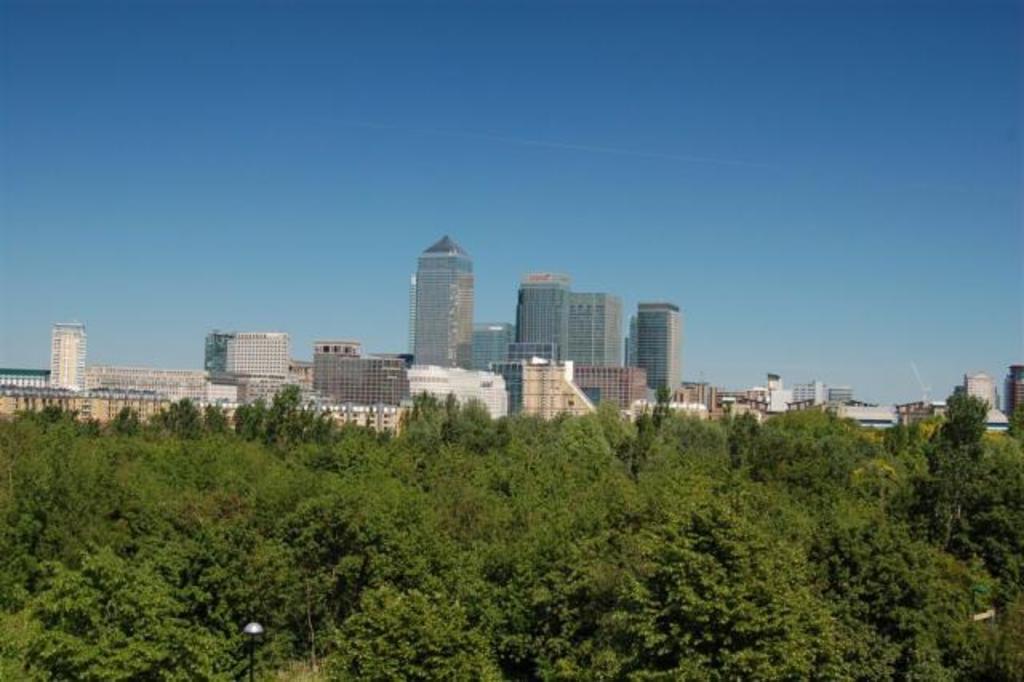In one or two sentences, can you explain what this image depicts? In this image I can see trees, poles and buildings. In the background I can see the sky. 